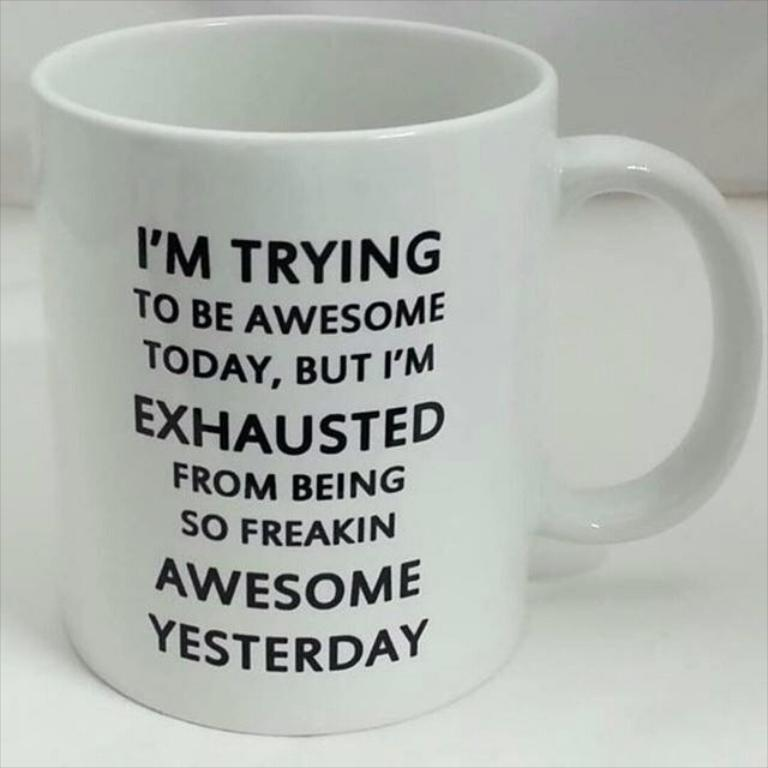<image>
Write a terse but informative summary of the picture. a white mug with a saying that reads i'm trying 